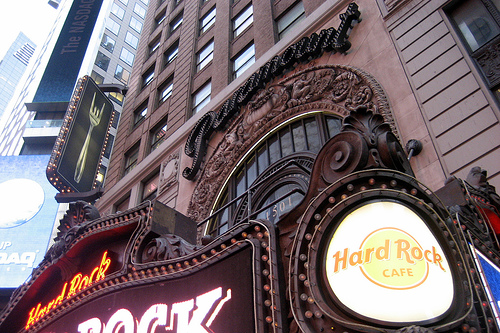<image>
Is there a sign in front of the arch? Yes. The sign is positioned in front of the arch, appearing closer to the camera viewpoint. 